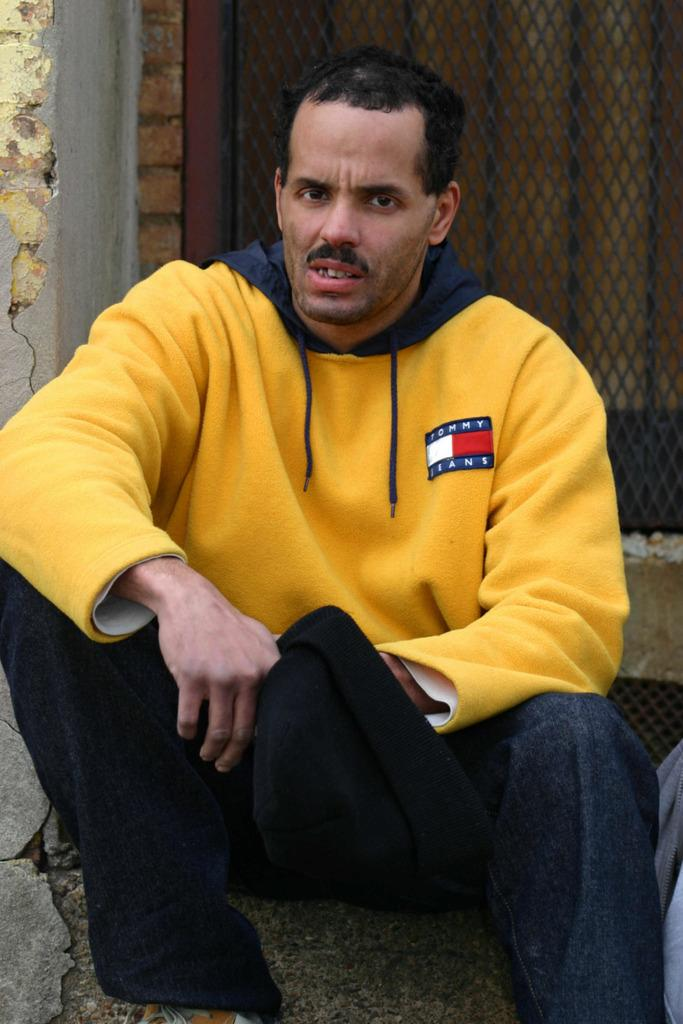<image>
Summarize the visual content of the image. A man with a Tommy Jeans, yellow sweatshirt is sitting down outside holding a hat in his hand. 